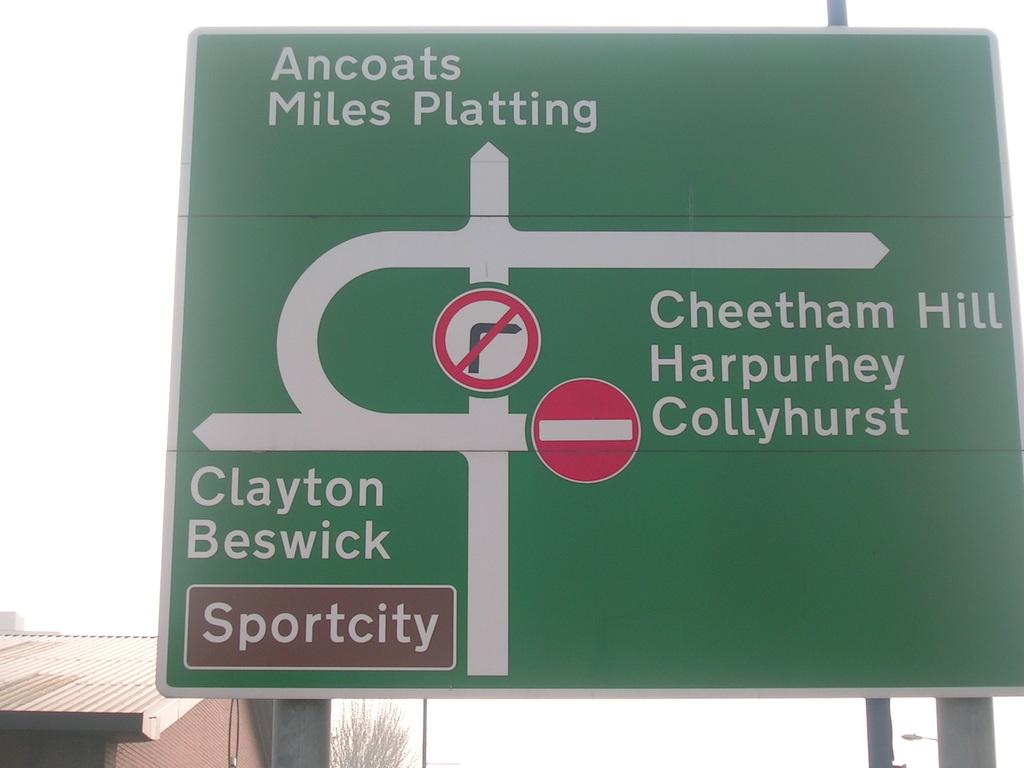<image>
Offer a succinct explanation of the picture presented. A sign for Sportcity shows a complicated road diagram. 